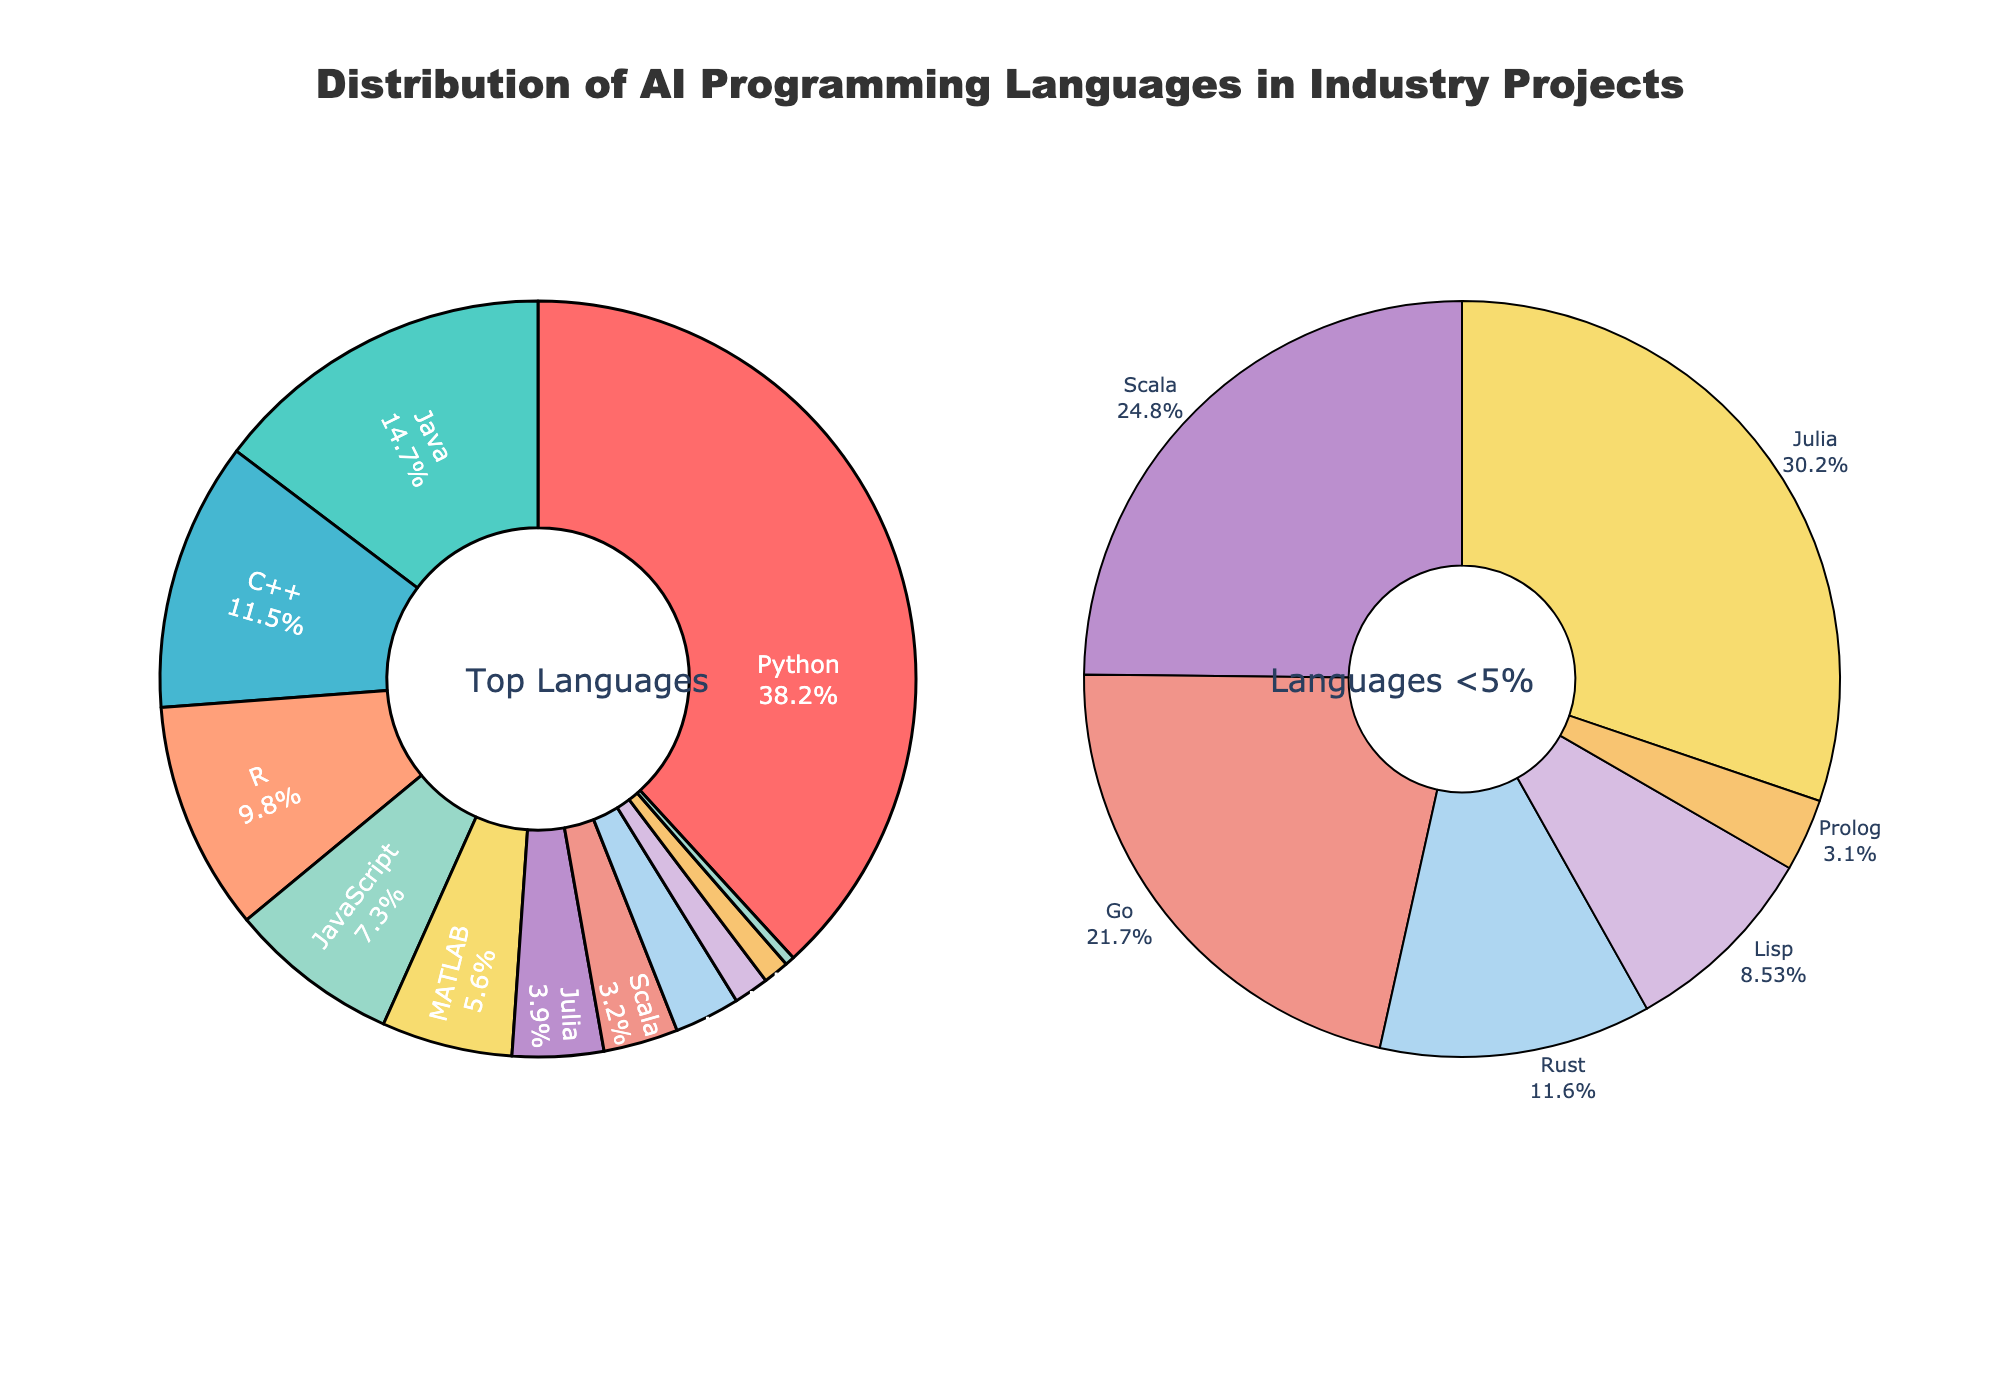What is the most commonly used AI programming language according to the pie chart? The largest segment of the pie chart represents Python, indicating it is the most commonly used AI programming language.
Answer: Python Which AI programming languages have a usage percentage greater than or equal to 10%? To find out which languages have a usage percentage greater than or equal to 10%, look at the segments with values above this threshold. Python, Java, and C++ all have usage percentages greater than or equal to 10%.
Answer: Python, Java, C++ What is the total percentage of AI programming languages used that individually account for less than 5%? Identify the languages in the smaller pie chart for those with less than 5%. Add their percentages together: MATLAB (5.6%), Julia (3.9%), Scala (3.2%), Go (2.8%), Rust (1.5%), Lisp (1.1%), and Prolog (0.4%). The sum is 5.6 + 3.9 + 3.2 + 2.8 + 1.5 + 1.1 + 0.4 = 18.5%.
Answer: 18.5% How does the percentage use of Java compare to JavaScript? Java has a segment with a percentage value of 14.7%, whereas JavaScript has 7.3%. So, Java is used more than JavaScript.
Answer: Java is used more than JavaScript Which AI programming languages are diversely colored in the pie chart and near each other in usage percentage? Find languages with distinct colors that have similar usage percentages. C++ (11.5%) and R (9.8%) fit this criterion as they have visually distinct segments and are close in percentage.
Answer: C++ and R 